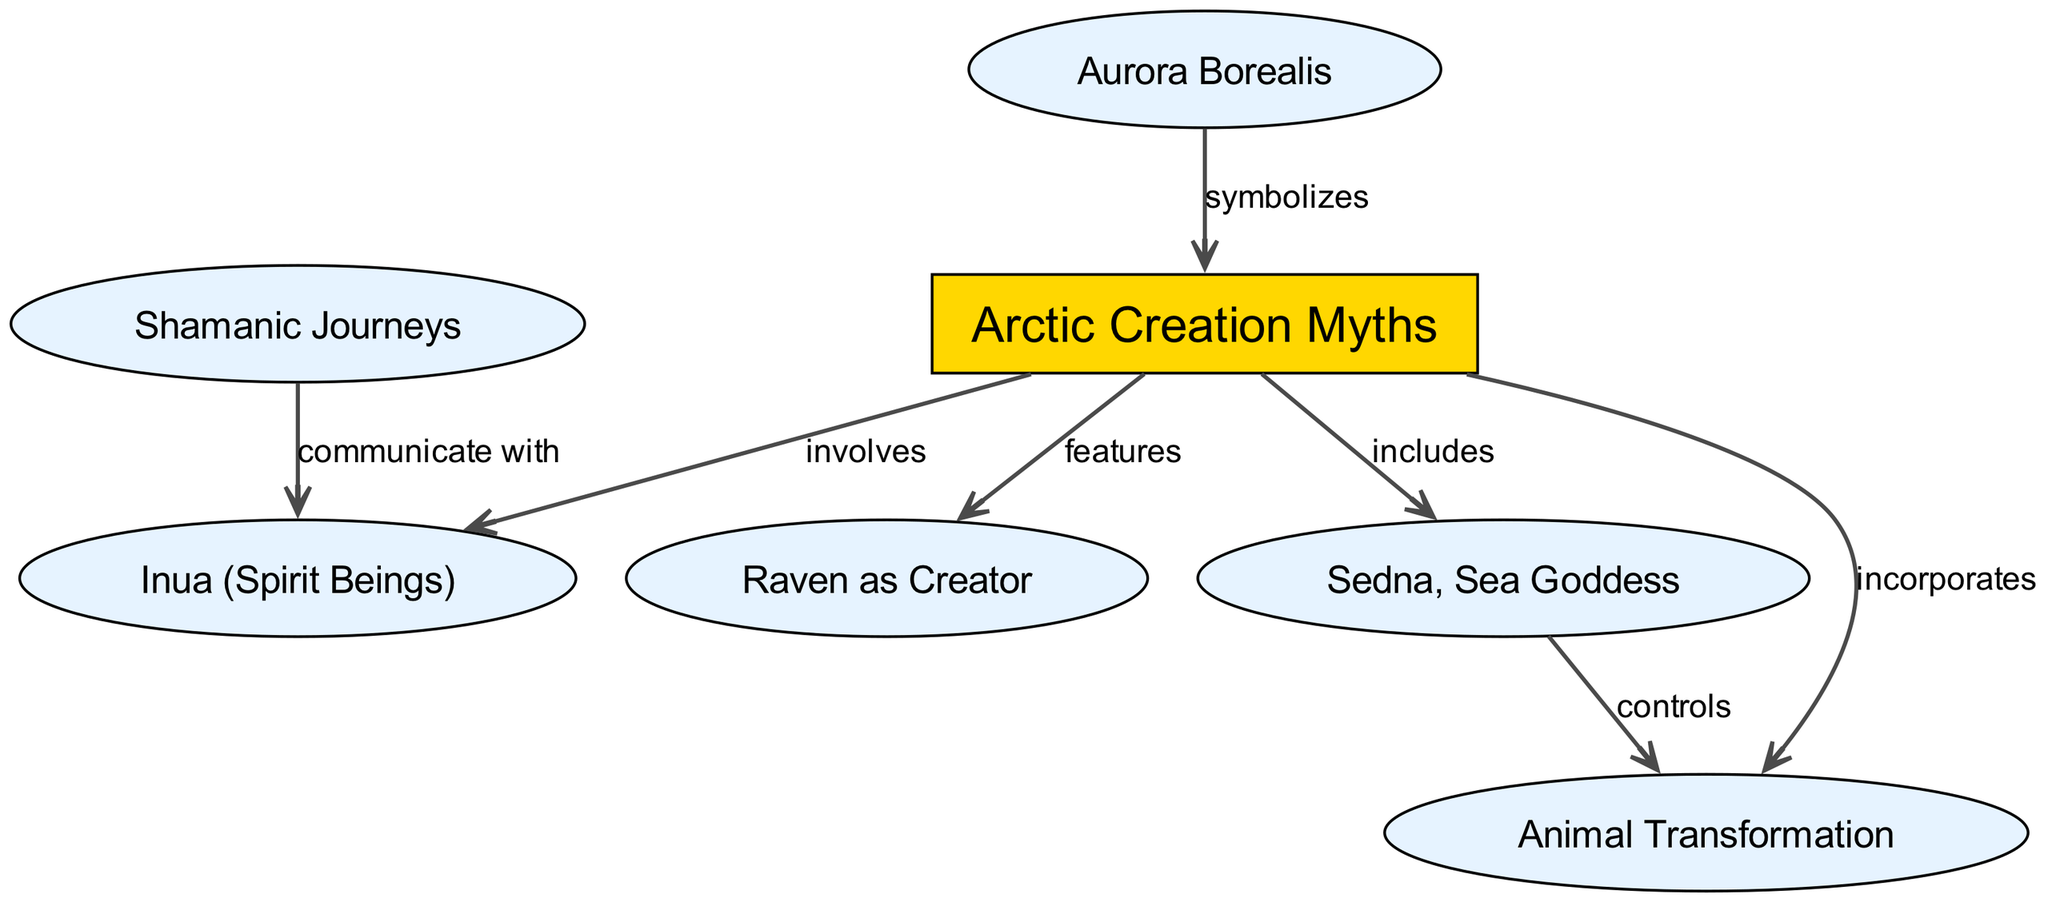What is the primary theme represented in the center of the diagram? The center node labeled "Arctic Creation Myths" represents the primary theme of the diagram and is connected to various elements indicating different aspects of these myths.
Answer: Arctic Creation Myths How many nodes are present in the diagram? The diagram features a total of seven nodes, which include the central theme and various related concepts.
Answer: 7 Which figure is associated with the concept of transformation in the diagram? The diagram shows "Animal Transformation" as a distinct concept linked to the central theme of Arctic Creation Myths, indicating its role in the overall narrative.
Answer: Animal Transformation What does Sedna control according to the diagram? The diagram indicates that "Sedna" directly "controls" "animals," illustrating her significant influence over them in the context of the creation myths.
Answer: animals How do shamans relate to the spirit beings in the concept map? The edge connecting "Shamans" to "Inua" shows that shamans communicate with the spirit beings, demonstrating their role in connecting the spiritual aspect of the myths.
Answer: communicate with What does the Aurora Borealis symbolize in the context of the Arctic creation myths? The diagram depicts an edge from "Aurora Borealis" to "Arctic Creation Myths," which indicates that it symbolizes or represents the myths themselves, adding a layer of meaning to the narrative.
Answer: symbolizes What is the relationship between Sedna and animals? The edge from "Sedna" to "animals" is labeled "controls," indicating a controlling relationship where Sedna has authority over animals in the mythological context.
Answer: controls Which character is featured as the creator in Arctic creation myths? The node labeled "Raven as Creator" from the diagram specifies that the character associated with creation is the Raven, highlighting its importance in these myths.
Answer: Raven as Creator How many edges are connecting to the "Arctic Creation Myths" node? The central node "Arctic Creation Myths" has five edges connecting it to other nodes, showing diverse relationships and components of the myths.
Answer: 5 